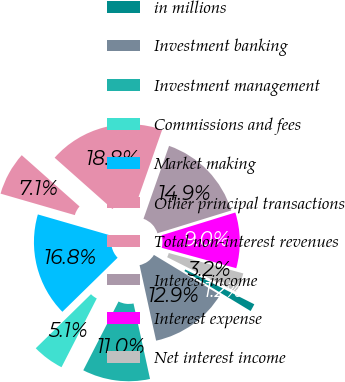Convert chart. <chart><loc_0><loc_0><loc_500><loc_500><pie_chart><fcel>in millions<fcel>Investment banking<fcel>Investment management<fcel>Commissions and fees<fcel>Market making<fcel>Other principal transactions<fcel>Total non-interest revenues<fcel>Interest income<fcel>Interest expense<fcel>Net interest income<nl><fcel>1.23%<fcel>12.91%<fcel>10.97%<fcel>5.13%<fcel>16.81%<fcel>7.07%<fcel>18.82%<fcel>14.86%<fcel>9.02%<fcel>3.18%<nl></chart> 